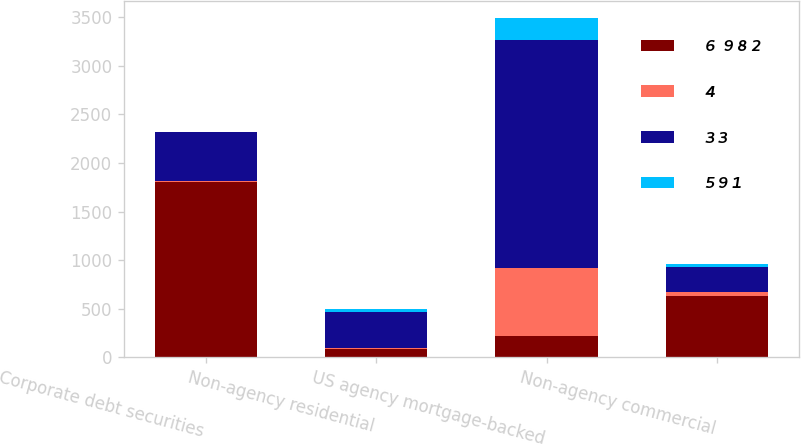<chart> <loc_0><loc_0><loc_500><loc_500><stacked_bar_chart><ecel><fcel>Corporate debt securities<fcel>Non-agency residential<fcel>US agency mortgage-backed<fcel>Non-agency commercial<nl><fcel>6  9 8 2<fcel>1802<fcel>89<fcel>223<fcel>630<nl><fcel>4<fcel>14<fcel>2<fcel>698<fcel>43<nl><fcel>3 3<fcel>499<fcel>374<fcel>2345<fcel>260<nl><fcel>5 9 1<fcel>1<fcel>32<fcel>223<fcel>25<nl></chart> 